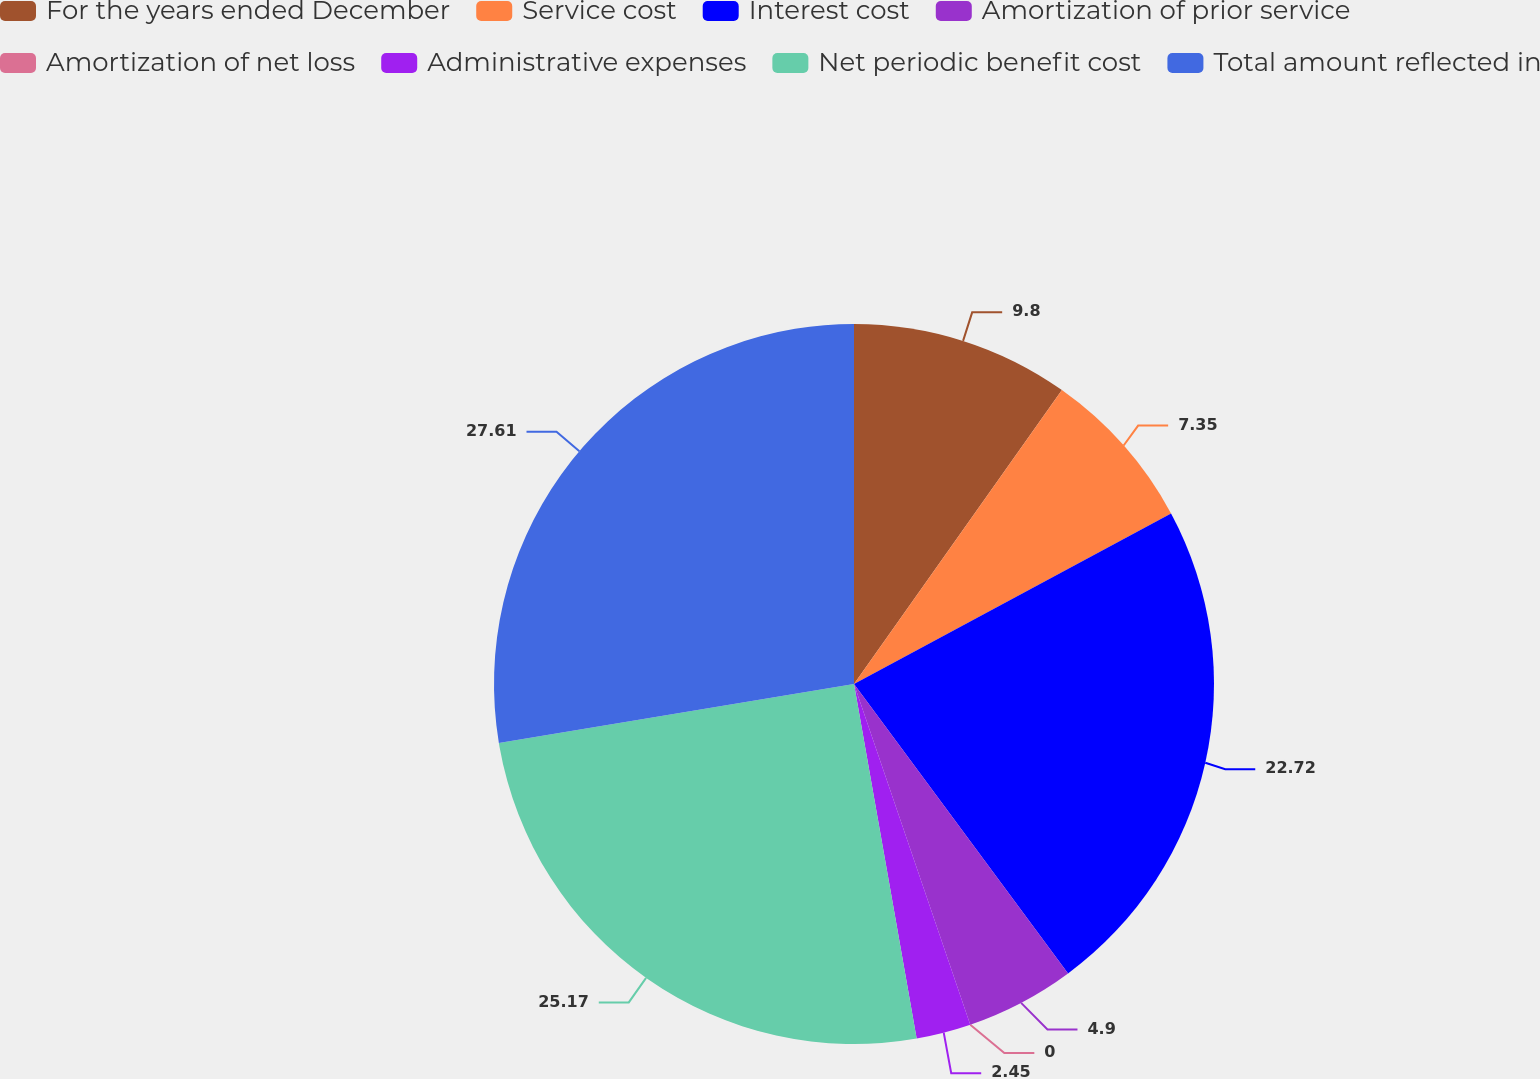<chart> <loc_0><loc_0><loc_500><loc_500><pie_chart><fcel>For the years ended December<fcel>Service cost<fcel>Interest cost<fcel>Amortization of prior service<fcel>Amortization of net loss<fcel>Administrative expenses<fcel>Net periodic benefit cost<fcel>Total amount reflected in<nl><fcel>9.8%<fcel>7.35%<fcel>22.72%<fcel>4.9%<fcel>0.0%<fcel>2.45%<fcel>25.17%<fcel>27.62%<nl></chart> 